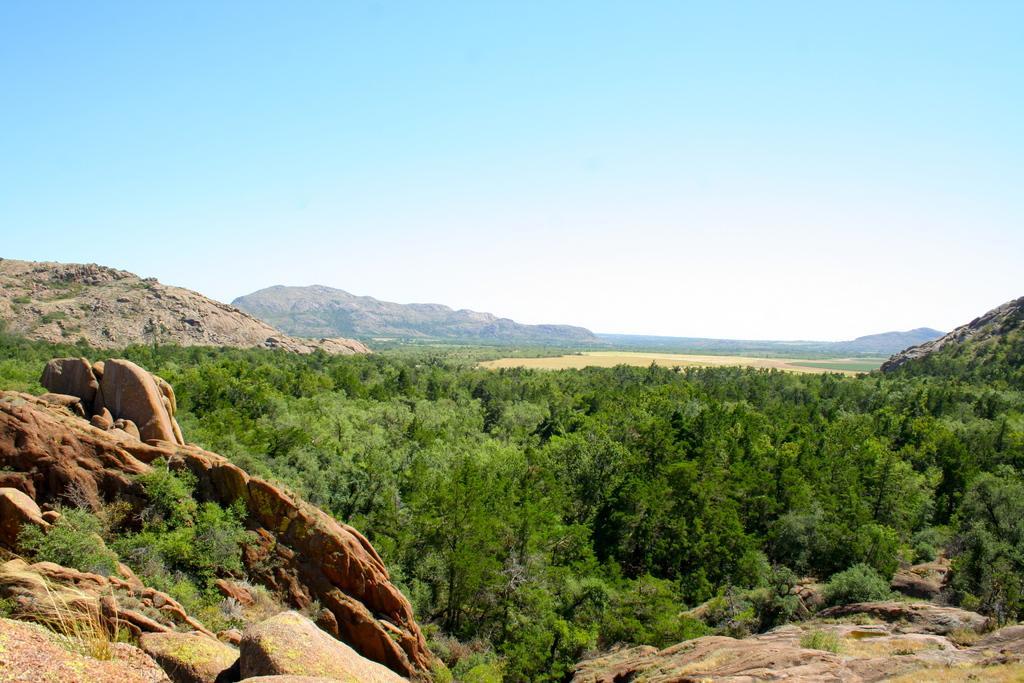How would you summarize this image in a sentence or two? In this image I can see the rocks and many trees. In the background I can see the mountains, clouds and the sky. 